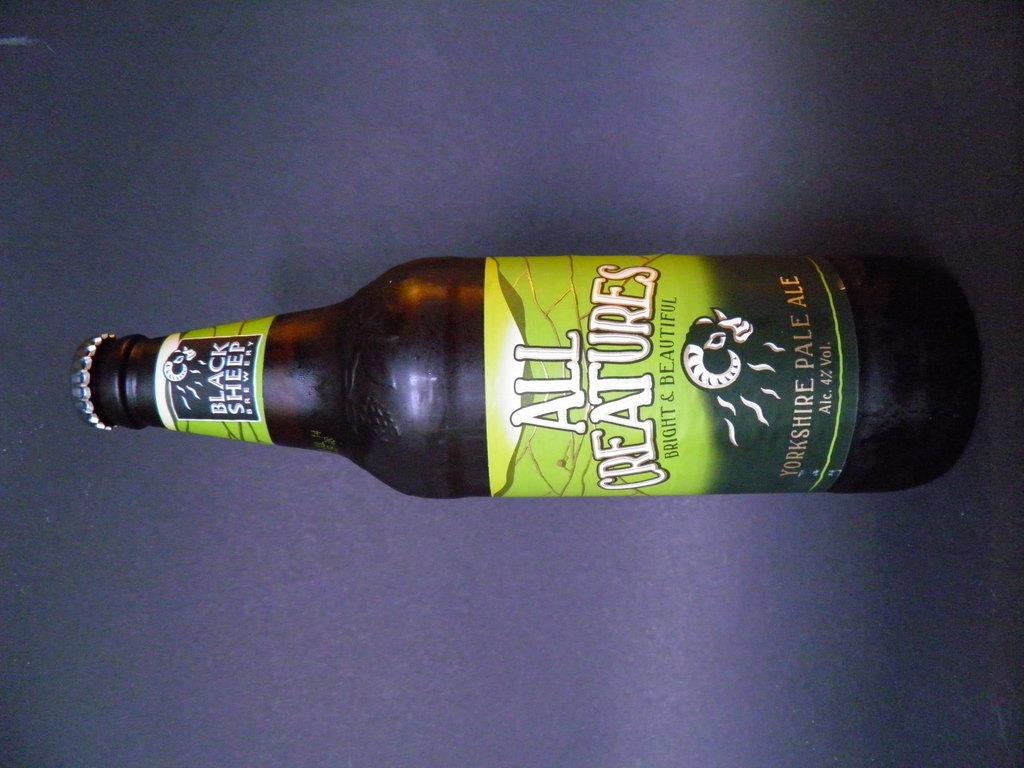Provide a one-sentence caption for the provided image. A sideways bottle of Black sheep all creatures ale. 